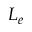Convert formula to latex. <formula><loc_0><loc_0><loc_500><loc_500>L _ { e }</formula> 